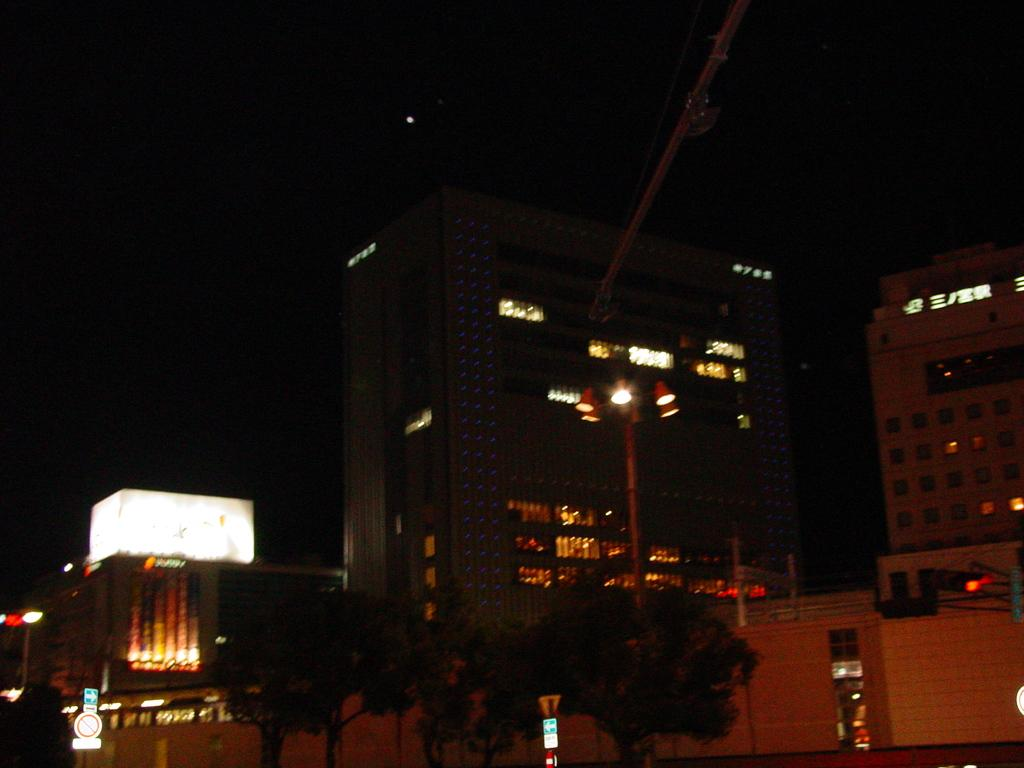Where was the image likely taken? The image appears to be taken outside. What can be seen in the background of the image? There are many buildings in the image. What part of the natural environment is visible in the image? Trees are present at the bottom of the image. What is visible at the top of the image? The sky is visible at the top of the image. What type of authority is depicted in the image? There is no authority figure present in the image. Can you describe the line formation of the people in the image? There are no people present in the image, so there is no line formation to describe. 